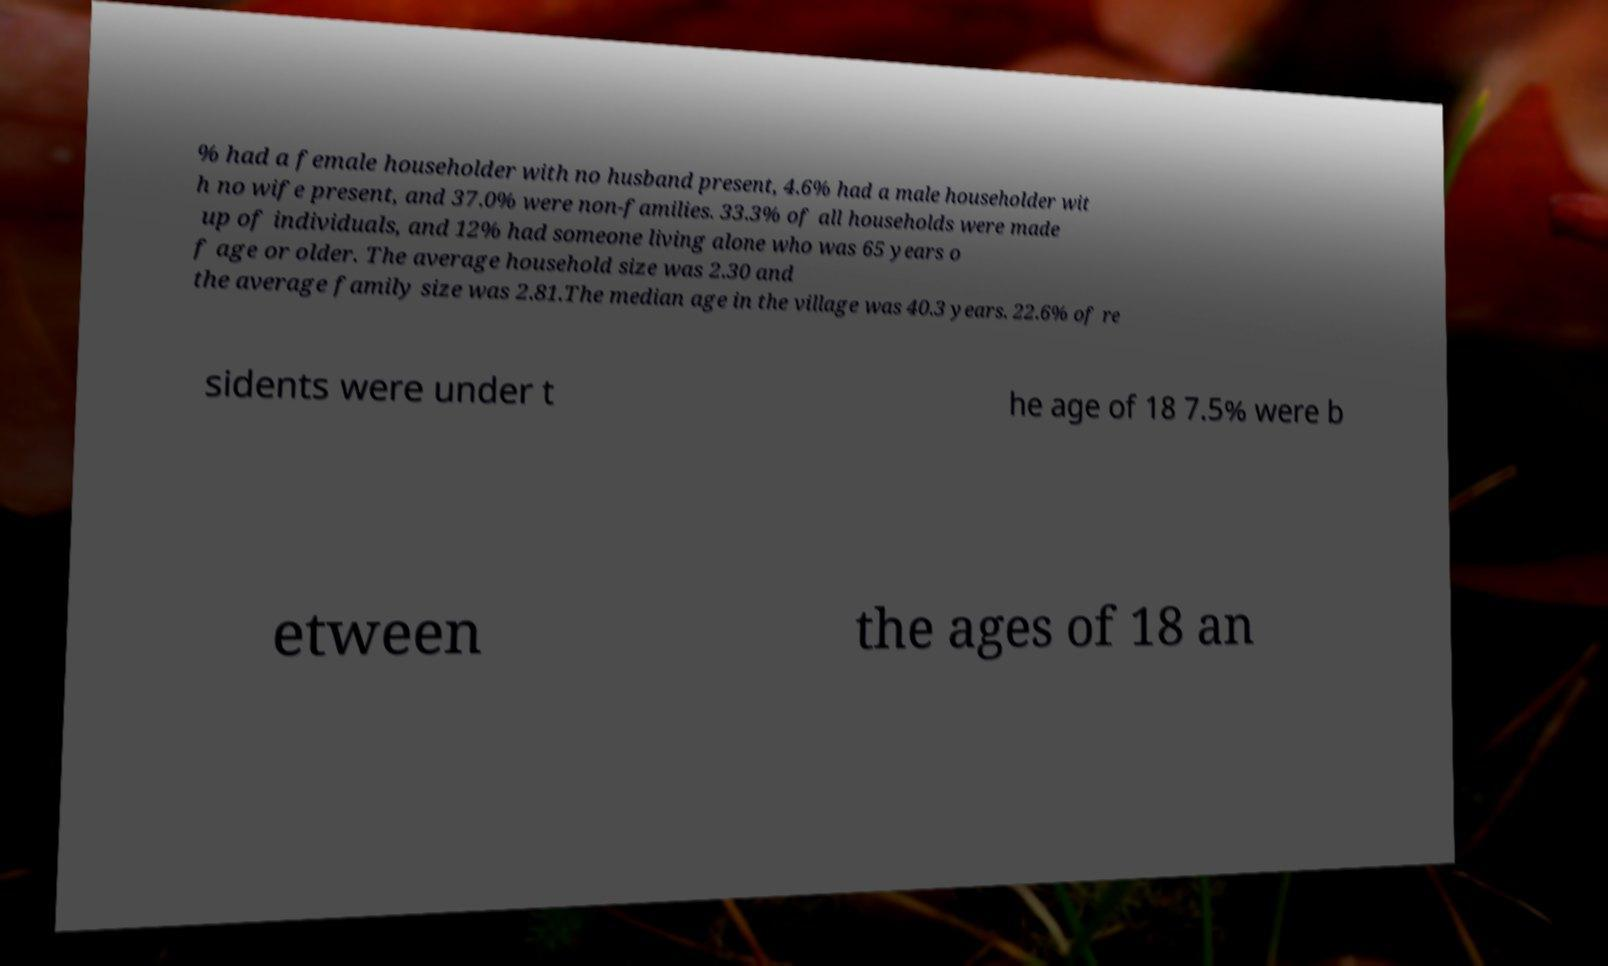I need the written content from this picture converted into text. Can you do that? % had a female householder with no husband present, 4.6% had a male householder wit h no wife present, and 37.0% were non-families. 33.3% of all households were made up of individuals, and 12% had someone living alone who was 65 years o f age or older. The average household size was 2.30 and the average family size was 2.81.The median age in the village was 40.3 years. 22.6% of re sidents were under t he age of 18 7.5% were b etween the ages of 18 an 